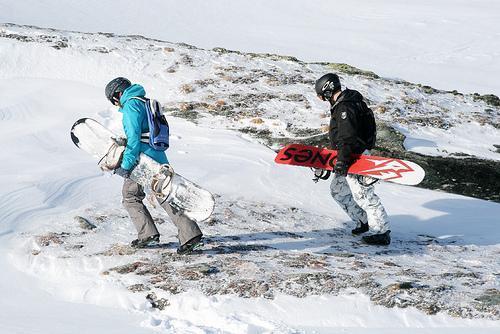How many men are there?
Give a very brief answer. 2. 